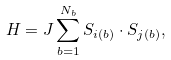Convert formula to latex. <formula><loc_0><loc_0><loc_500><loc_500>H = J \sum _ { b = 1 } ^ { N _ { b } } { S } _ { i ( b ) } \cdot { S } _ { j ( b ) } ,</formula> 